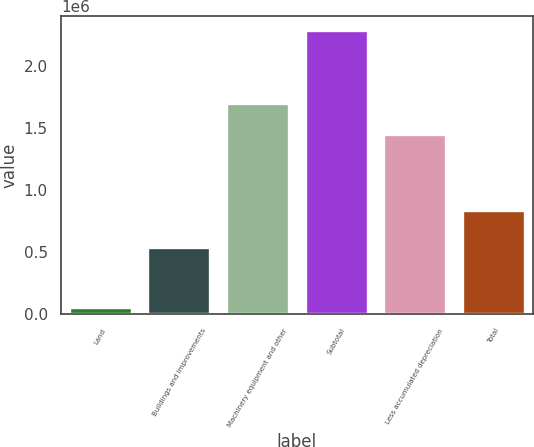Convert chart to OTSL. <chart><loc_0><loc_0><loc_500><loc_500><bar_chart><fcel>Land<fcel>Buildings and improvements<fcel>Machinery equipment and other<fcel>Subtotal<fcel>Less accumulated depreciation<fcel>Total<nl><fcel>55076<fcel>537474<fcel>1.69864e+06<fcel>2.29119e+06<fcel>1.45412e+06<fcel>837069<nl></chart> 